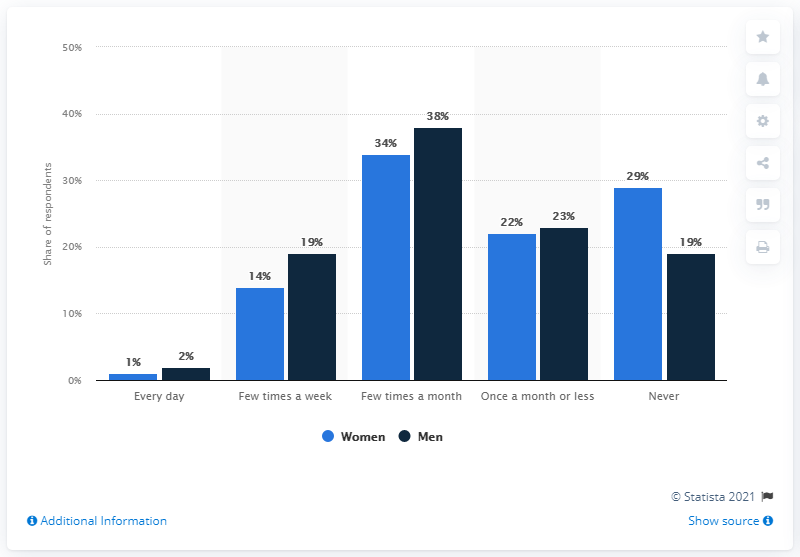Highlight a few significant elements in this photo. Forty-eight people say that they never do something. The ratio of women to men is approximately 0.5, meaning that there are 0.5 women for every man. 